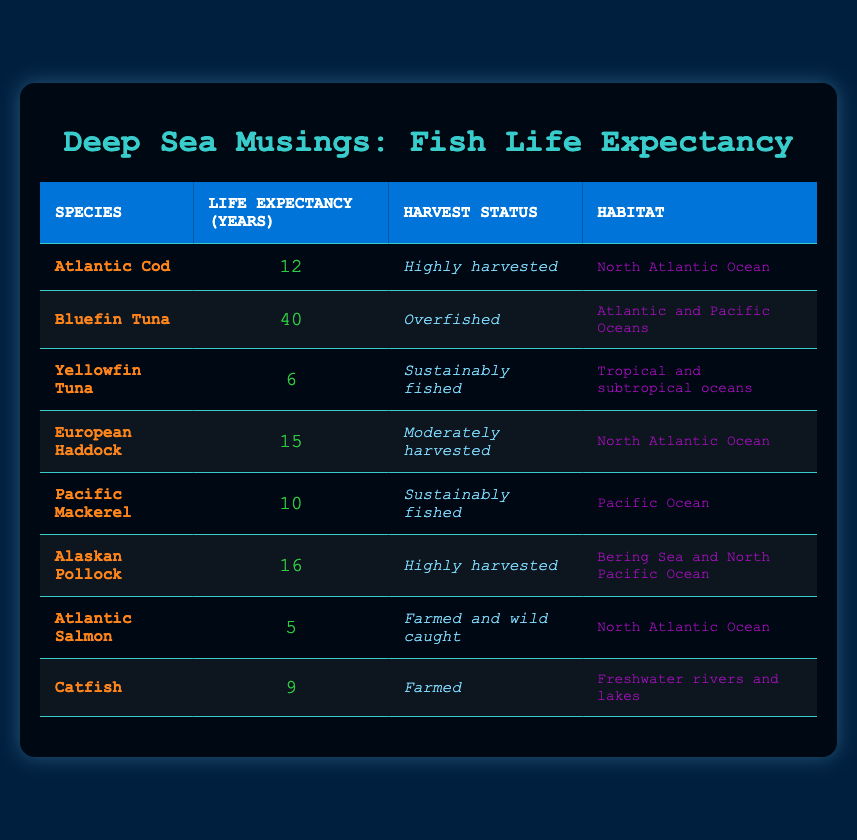What is the life expectancy of Bluefin Tuna? In the table, I look for the row that lists Bluefin Tuna and find the corresponding value in the "Life Expectancy (Years)" column, which is 40.
Answer: 40 Which species has the shortest life expectancy? By examining all the life expectancy values in the table, I see that Atlantic Salmon has the lowest value of 5 years.
Answer: Atlantic Salmon Are all the fish species listed in the table commercially harvested? I check the "Harvest Status" column and find that while most species are commercially harvested, Atlantic Salmon is noted as "Farmed and wild caught," which indicates it is not limited to commercial harvesting only.
Answer: No What is the average life expectancy of sustainably fished species? I identify the sustainably fished species: Yellowfin Tuna (6 years) and Pacific Mackerel (10 years). Then, I calculate the average: (6 + 10) / 2 = 8.
Answer: 8 How many species have a life expectancy greater than 10 years? I review the life expectancy column, noting the species with life expectancies of more than 10: Bluefin Tuna (40), European Haddock (15), Alaskan Pollock (16), which gives us a total of 3 species.
Answer: 3 What is the cumulative life expectancy of the highly harvested species? I find the highly harvested species and their life expectancies: Atlantic Cod (12), Alaskan Pollock (16). The sum is 12 + 16 = 28.
Answer: 28 Is the Atlantic Cod's life expectancy less than the average life expectancy of all listed fish species? First, I find the life expectancy of Atlantic Cod, which is 12 years. Next, I calculate the overall average: (12 + 40 + 6 + 15 + 10 + 16 + 5 + 9) / 8 = 12. That indicates the average is also 12; thus, it is not less.
Answer: No How does the life expectancy of Alaskan Pollock compare to that of Atlantic Salmon? I observe that Alaskan Pollock has an average life expectancy of 16 years, while Atlantic Salmon's life expectancy is only 5 years. Therefore, Alaskan Pollock lives significantly longer than Atlantic Salmon.
Answer: Longer 